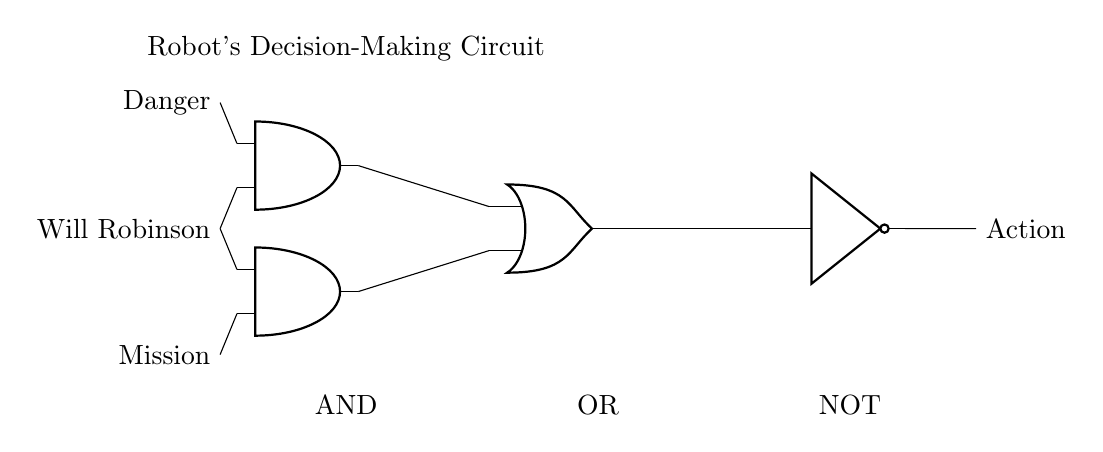What logic gates are used in this circuit? The circuit contains two AND gates, one OR gate, and one NOT gate, which are identified by their respective symbols on the diagram.
Answer: AND, OR, NOT What are the inputs to the first AND gate? The first AND gate is connected to the inputs labeled "Danger" and "Will Robinson," which are drawn as lines entering the left side of the gate.
Answer: Danger, Will Robinson How many output actions does the circuit produce? The circuit has a single output labeled "Action" that comes from the NOT gate at the end of the circuit.
Answer: One What is the purpose of the NOT gate in this circuit? The NOT gate inverts the output of the OR gate, changing the resulting signal to its opposite, which affects the final action decision of the robot.
Answer: Inverts output Which two inputs must be true for the first AND gate to output true? Both the "Danger" and "Will Robinson" inputs must be true for the first AND gate to produce a true output. This is due to the nature of AND gates requiring all inputs to be true.
Answer: Danger, Will Robinson What will happen if the "Mission" input is true and "Will Robinson" is false? In this case, the second AND gate outputs false, as one input is false, which means the output to the OR gate will also be false, affecting the final action.
Answer: Output is false 